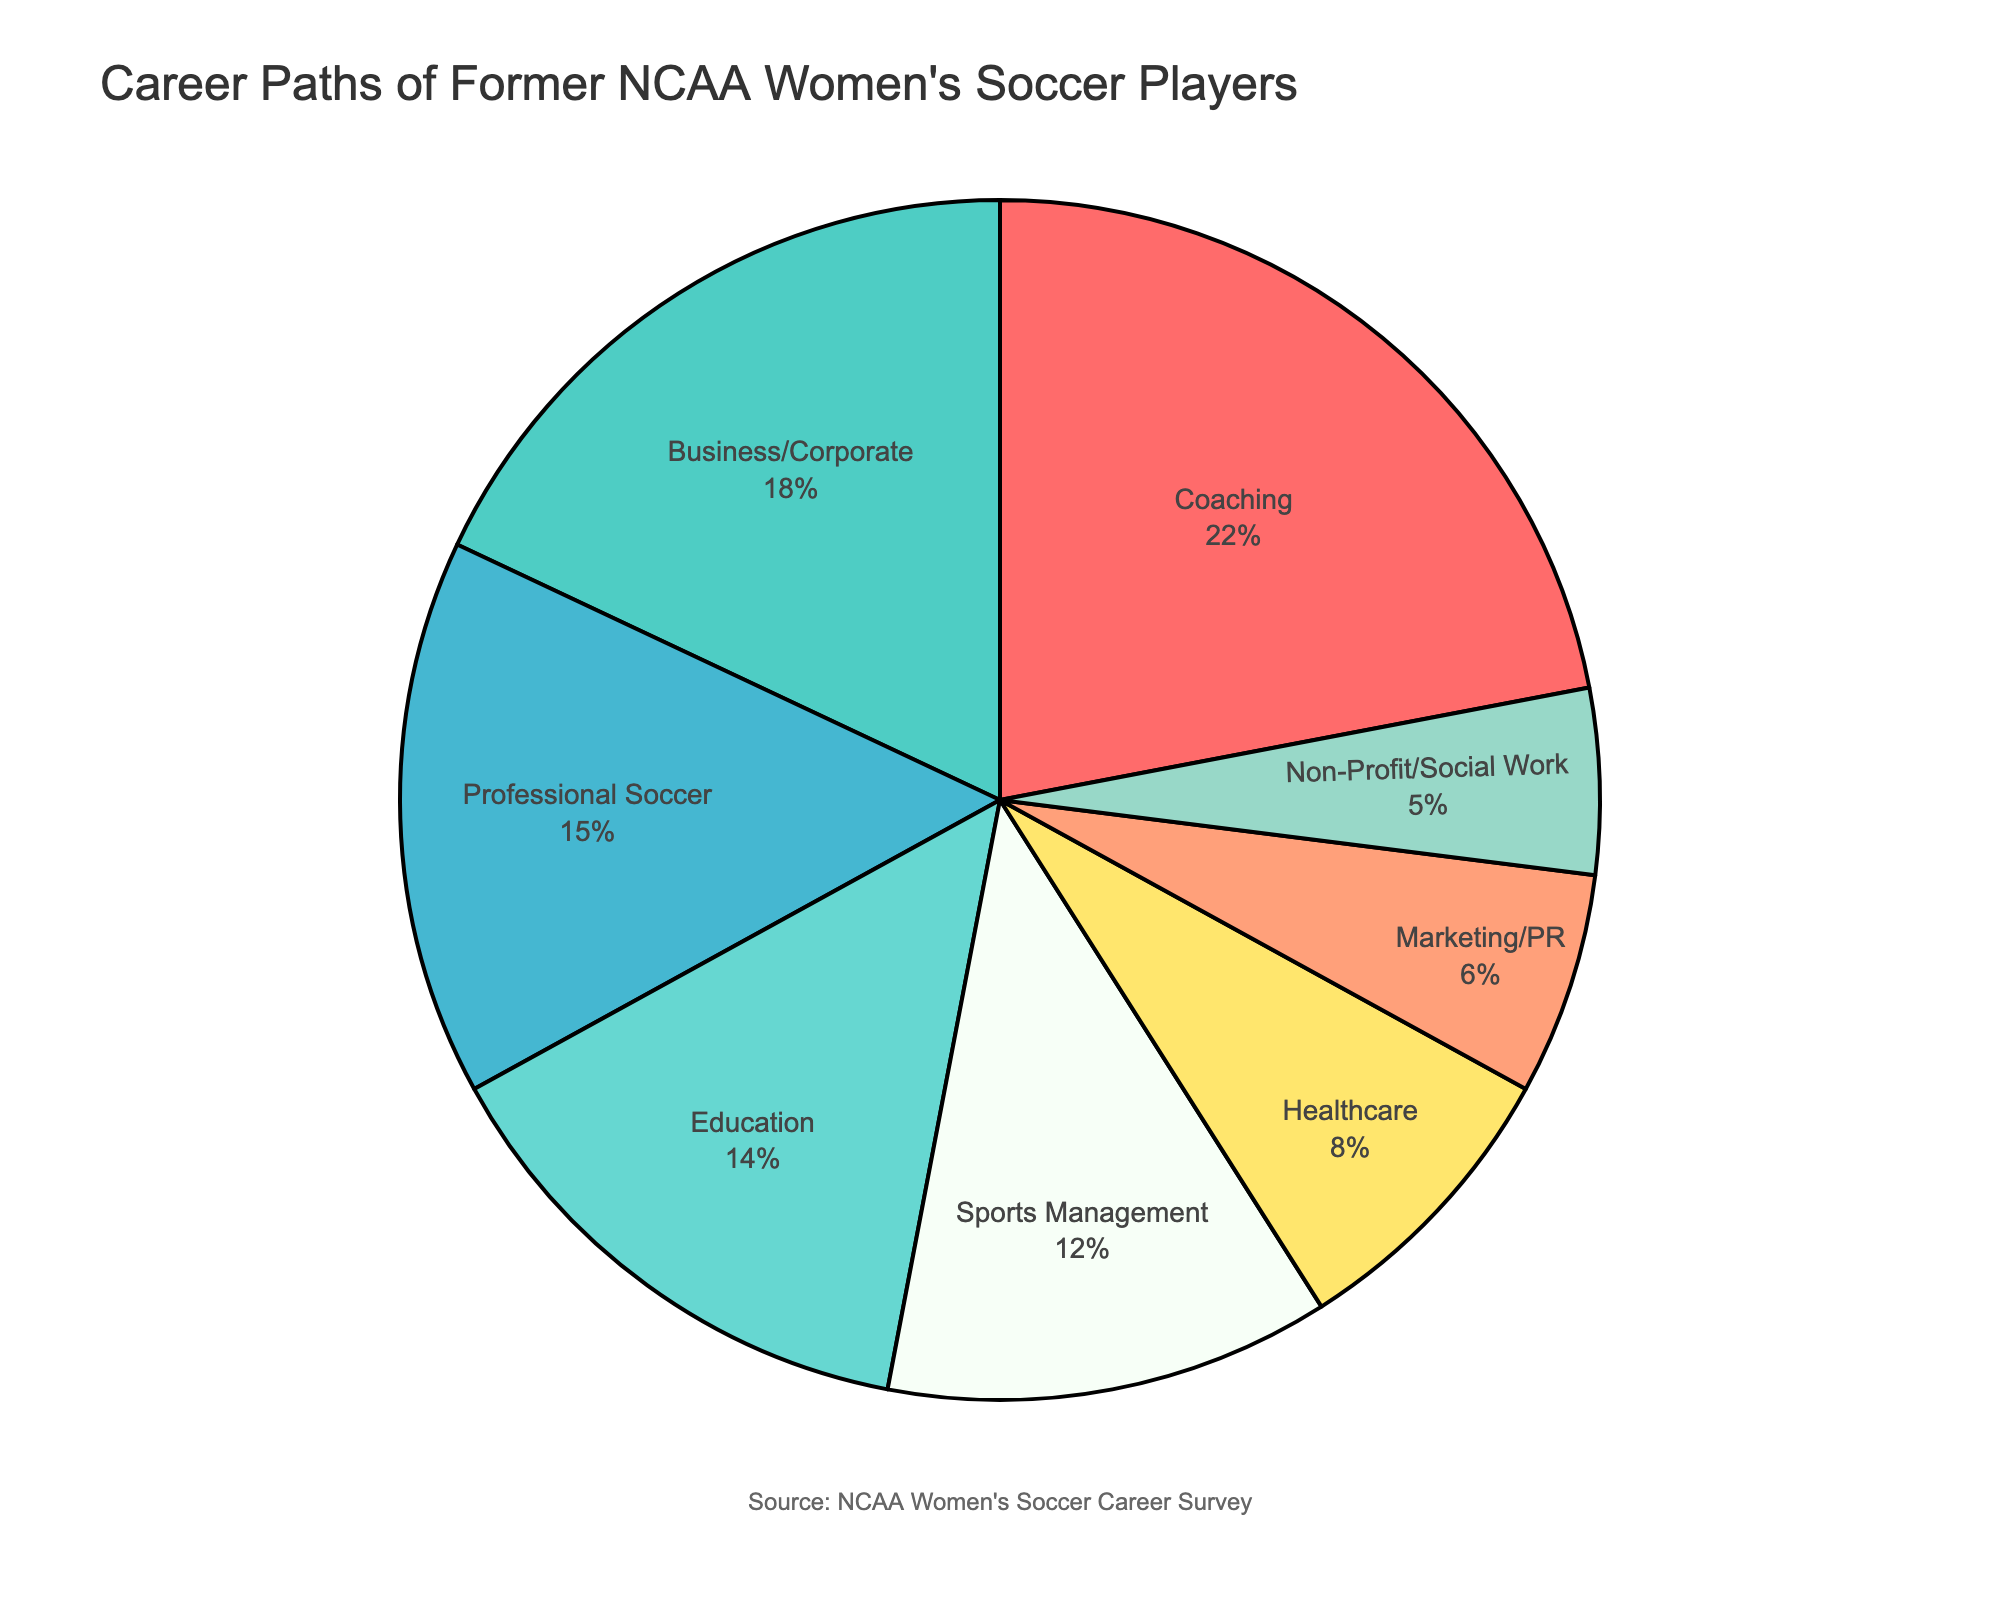What career path has the second highest percentage of former NCAA women's soccer players? First, we need to identify the career path with the highest percentage, which is 'Coaching' at 22%. Next, check the career path with the second highest percentage by scanning the remaining values. 'Business/Corporate' with 18% comes next after 'Coaching.'
Answer: Business/Corporate Which career path occupies a larger percentage: Healthcare or Education? Compare the two percentages directly from the pie chart. 'Healthcare' stands at 8%, while 'Education' is at 14%.
Answer: Education What is the combined percentage of former NCAA women's soccer players working in Non-Profit/Social Work and Marketing/PR? Add the percentages of 'Non-Profit/Social Work' (5%) and 'Marketing/PR' (6%). The combined percentage is 5% + 6% = 11%.
Answer: 11% How does the percentage of players in Professional Soccer compare to those in Sports Management? Compare the percentages directly from the pie chart. 'Professional Soccer' (15%) and 'Sports Management' (12%). 'Professional Soccer' has a higher percentage.
Answer: Professional Soccer What career path corresponds to the green section in the pie chart? Look for the green color section in the pie chart. Based on the color scheme used in the chart, the green section corresponds to 'Coaching.'
Answer: Coaching What is the difference in percentage between players in Education and players in Healthcare? Subtract the percentage of 'Healthcare' (8%) from 'Education' (14%). The difference is 14% - 8% = 6%.
Answer: 6% Which career path corresponds to the smallest section of the pie chart? Identify the smallest section of the pie chart which represents the lowest percentage. 'Non-Profit/Social Work' has the smallest percentage at 5%.
Answer: Non-Profit/Social Work What is the average percentage of players in Business/Corporate, Education, and Healthcare? To find the average, sum the percentages for 'Business/Corporate' (18%), 'Education' (14%), and 'Healthcare' (8%) and then divide by the number of categories (3). (18% + 14% + 8%) / 3 = 13.33%.
Answer: 13.33% Is the percentage of former players in Marketing/PR greater than in Non-Profit/Social Work? Compare the percentages directly from the pie chart. 'Marketing/PR' is 6%, and 'Non-Profit/Social Work' is 5%. 'Marketing/PR' has a slightly higher percentage.
Answer: Yes 